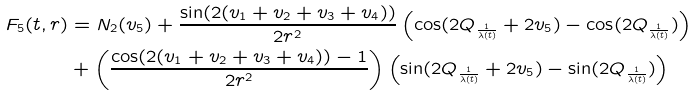<formula> <loc_0><loc_0><loc_500><loc_500>F _ { 5 } ( t , r ) & = N _ { 2 } ( v _ { 5 } ) + \frac { \sin ( 2 ( v _ { 1 } + v _ { 2 } + v _ { 3 } + v _ { 4 } ) ) } { 2 r ^ { 2 } } \left ( \cos ( 2 Q _ { \frac { 1 } { \lambda ( t ) } } + 2 v _ { 5 } ) - \cos ( 2 Q _ { \frac { 1 } { \lambda ( t ) } } ) \right ) \\ & + \left ( \frac { \cos ( 2 ( v _ { 1 } + v _ { 2 } + v _ { 3 } + v _ { 4 } ) ) - 1 } { 2 r ^ { 2 } } \right ) \left ( \sin ( 2 Q _ { \frac { 1 } { \lambda ( t ) } } + 2 v _ { 5 } ) - \sin ( 2 Q _ { \frac { 1 } { \lambda ( t ) } } ) \right )</formula> 